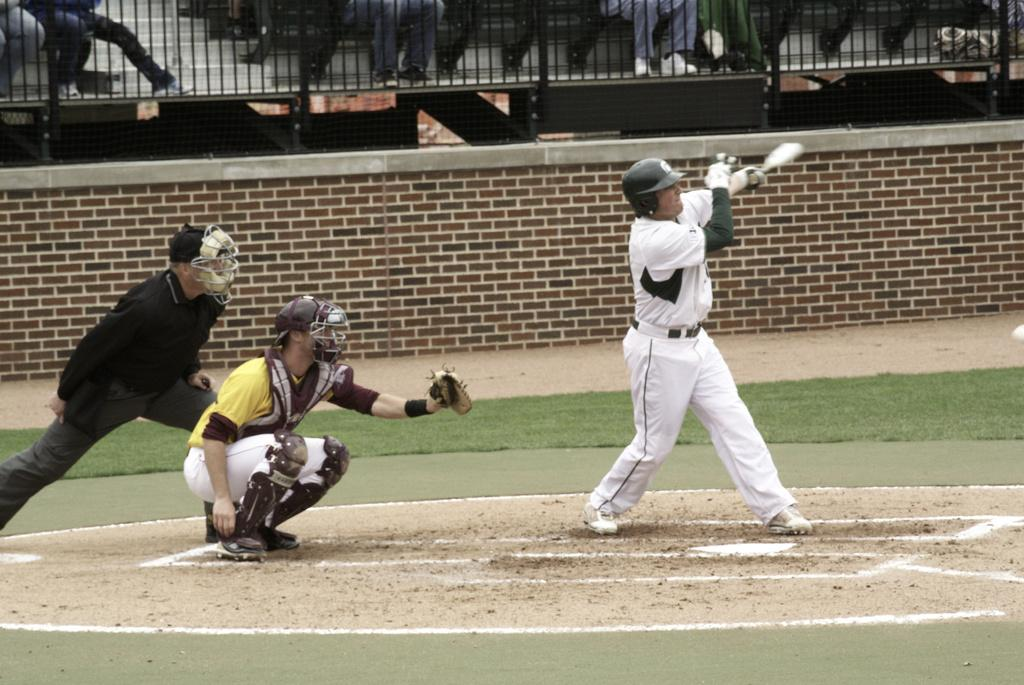What are the people in the image doing? The people in the image are playing on the ground. What protective gear are the people wearing? The people are wearing helmets. What can be seen in the background of the image? There is a boundary wall and fencing in the background of the image. Are there any other people visible in the image? Yes, people are present behind the fencing. What type of muscle is being exercised by the people in the image? The image does not provide information about the specific muscles being exercised by the people. What authority figure can be seen in the image? There is no authority figure present in the image. 